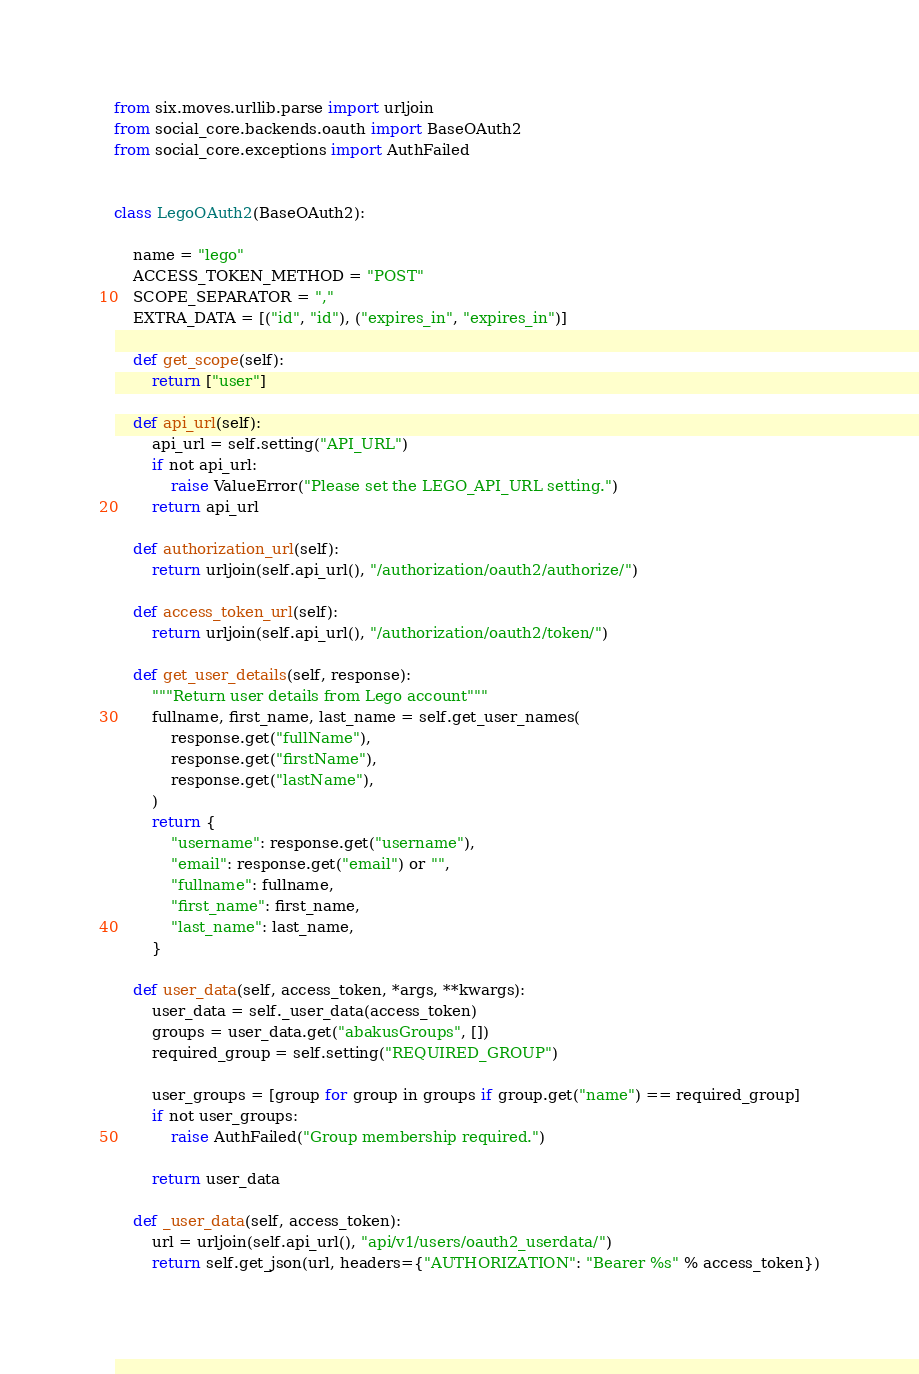Convert code to text. <code><loc_0><loc_0><loc_500><loc_500><_Python_>from six.moves.urllib.parse import urljoin
from social_core.backends.oauth import BaseOAuth2
from social_core.exceptions import AuthFailed


class LegoOAuth2(BaseOAuth2):

    name = "lego"
    ACCESS_TOKEN_METHOD = "POST"
    SCOPE_SEPARATOR = ","
    EXTRA_DATA = [("id", "id"), ("expires_in", "expires_in")]

    def get_scope(self):
        return ["user"]

    def api_url(self):
        api_url = self.setting("API_URL")
        if not api_url:
            raise ValueError("Please set the LEGO_API_URL setting.")
        return api_url

    def authorization_url(self):
        return urljoin(self.api_url(), "/authorization/oauth2/authorize/")

    def access_token_url(self):
        return urljoin(self.api_url(), "/authorization/oauth2/token/")

    def get_user_details(self, response):
        """Return user details from Lego account"""
        fullname, first_name, last_name = self.get_user_names(
            response.get("fullName"),
            response.get("firstName"),
            response.get("lastName"),
        )
        return {
            "username": response.get("username"),
            "email": response.get("email") or "",
            "fullname": fullname,
            "first_name": first_name,
            "last_name": last_name,
        }

    def user_data(self, access_token, *args, **kwargs):
        user_data = self._user_data(access_token)
        groups = user_data.get("abakusGroups", [])
        required_group = self.setting("REQUIRED_GROUP")

        user_groups = [group for group in groups if group.get("name") == required_group]
        if not user_groups:
            raise AuthFailed("Group membership required.")

        return user_data

    def _user_data(self, access_token):
        url = urljoin(self.api_url(), "api/v1/users/oauth2_userdata/")
        return self.get_json(url, headers={"AUTHORIZATION": "Bearer %s" % access_token})
</code> 